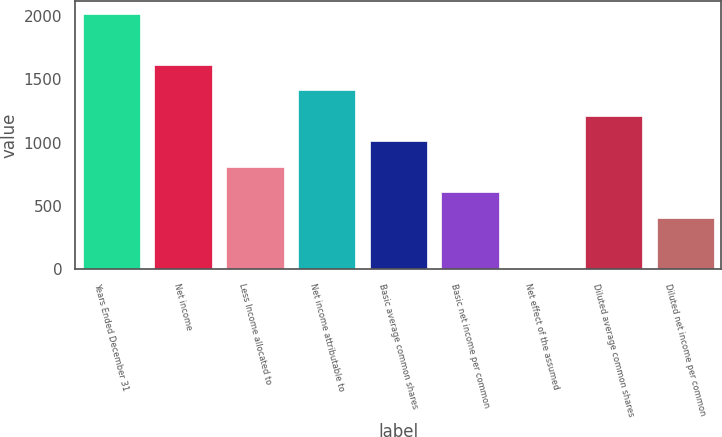Convert chart to OTSL. <chart><loc_0><loc_0><loc_500><loc_500><bar_chart><fcel>Years Ended December 31<fcel>Net income<fcel>Less Income allocated to<fcel>Net income attributable to<fcel>Basic average common shares<fcel>Basic net income per common<fcel>Net effect of the assumed<fcel>Diluted average common shares<fcel>Diluted net income per common<nl><fcel>2018<fcel>1614.6<fcel>807.8<fcel>1412.9<fcel>1009.5<fcel>606.1<fcel>1<fcel>1211.2<fcel>404.4<nl></chart> 